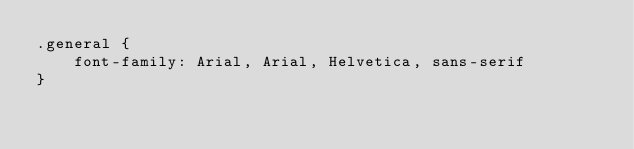<code> <loc_0><loc_0><loc_500><loc_500><_CSS_>.general {
    font-family: Arial, Arial, Helvetica, sans-serif
}</code> 